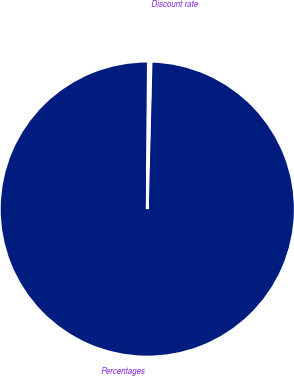Convert chart to OTSL. <chart><loc_0><loc_0><loc_500><loc_500><pie_chart><fcel>Percentages<fcel>Discount rate<nl><fcel>99.72%<fcel>0.28%<nl></chart> 